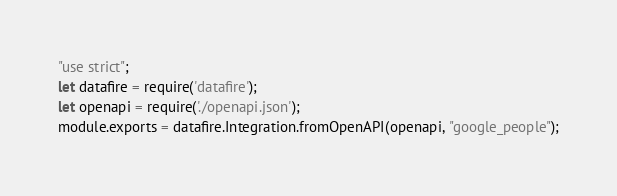Convert code to text. <code><loc_0><loc_0><loc_500><loc_500><_JavaScript_>"use strict";
let datafire = require('datafire');
let openapi = require('./openapi.json');
module.exports = datafire.Integration.fromOpenAPI(openapi, "google_people");</code> 